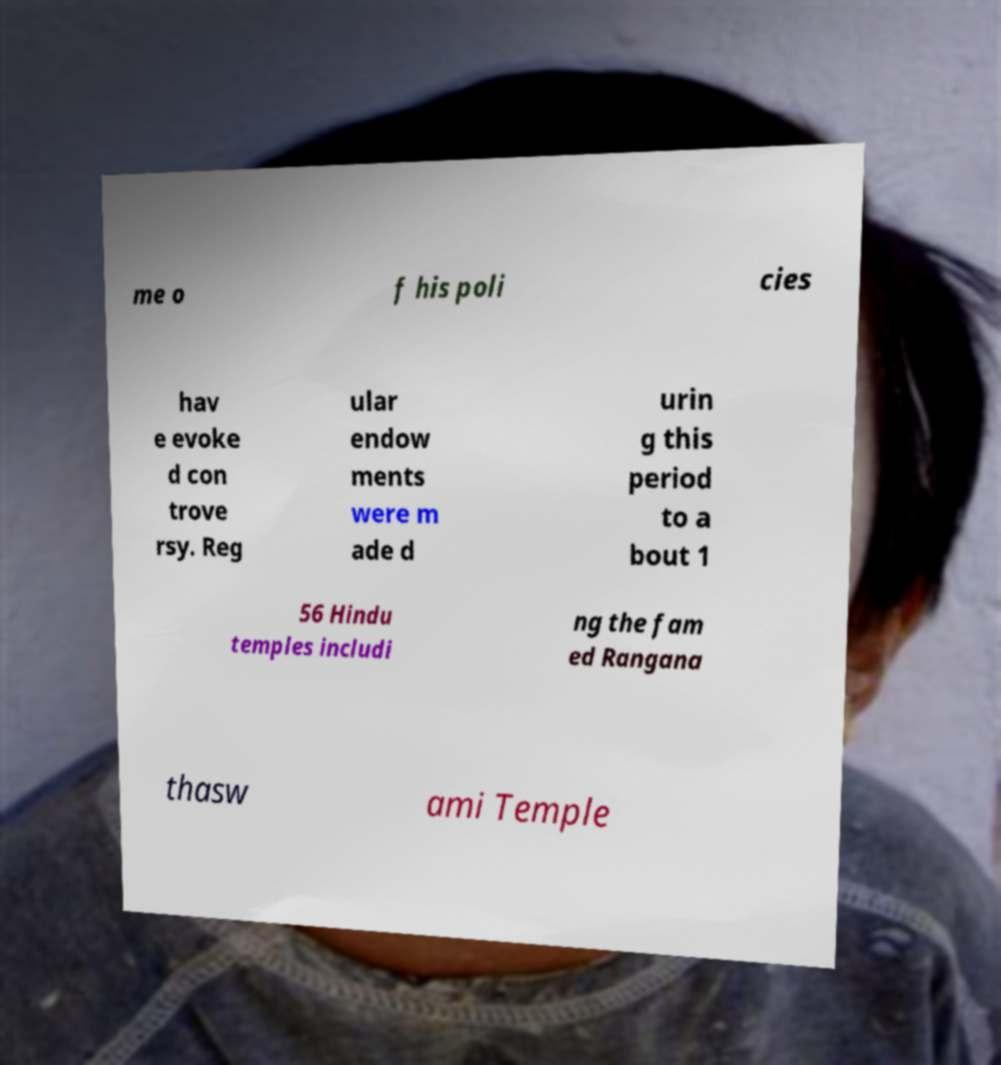Please read and relay the text visible in this image. What does it say? me o f his poli cies hav e evoke d con trove rsy. Reg ular endow ments were m ade d urin g this period to a bout 1 56 Hindu temples includi ng the fam ed Rangana thasw ami Temple 